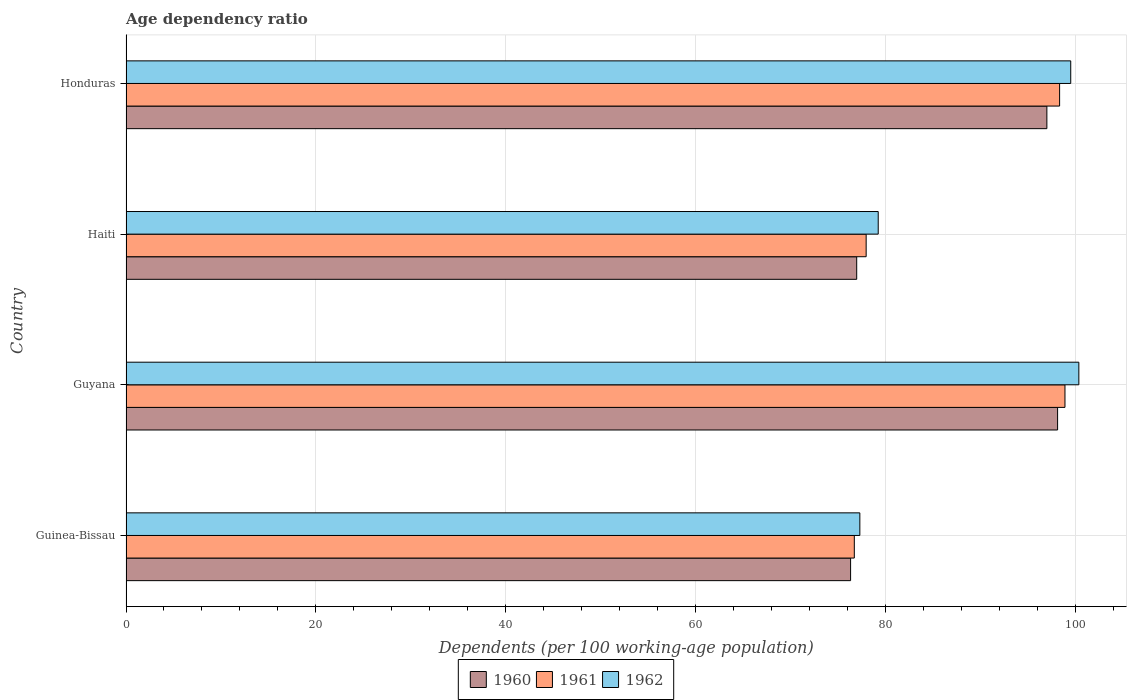How many different coloured bars are there?
Give a very brief answer. 3. How many groups of bars are there?
Offer a very short reply. 4. Are the number of bars per tick equal to the number of legend labels?
Give a very brief answer. Yes. What is the label of the 1st group of bars from the top?
Give a very brief answer. Honduras. In how many cases, is the number of bars for a given country not equal to the number of legend labels?
Offer a terse response. 0. What is the age dependency ratio in in 1962 in Guyana?
Offer a very short reply. 100.39. Across all countries, what is the maximum age dependency ratio in in 1962?
Provide a succinct answer. 100.39. Across all countries, what is the minimum age dependency ratio in in 1961?
Give a very brief answer. 76.74. In which country was the age dependency ratio in in 1962 maximum?
Make the answer very short. Guyana. In which country was the age dependency ratio in in 1962 minimum?
Keep it short and to the point. Guinea-Bissau. What is the total age dependency ratio in in 1960 in the graph?
Your answer should be compact. 348.51. What is the difference between the age dependency ratio in in 1962 in Guinea-Bissau and that in Honduras?
Your answer should be compact. -22.22. What is the difference between the age dependency ratio in in 1961 in Honduras and the age dependency ratio in in 1962 in Guinea-Bissau?
Your answer should be compact. 21.05. What is the average age dependency ratio in in 1962 per country?
Your answer should be very brief. 89.13. What is the difference between the age dependency ratio in in 1960 and age dependency ratio in in 1961 in Guyana?
Your response must be concise. -0.78. In how many countries, is the age dependency ratio in in 1961 greater than 44 %?
Your answer should be very brief. 4. What is the ratio of the age dependency ratio in in 1961 in Haiti to that in Honduras?
Ensure brevity in your answer.  0.79. Is the difference between the age dependency ratio in in 1960 in Guyana and Haiti greater than the difference between the age dependency ratio in in 1961 in Guyana and Haiti?
Offer a very short reply. Yes. What is the difference between the highest and the second highest age dependency ratio in in 1962?
Offer a terse response. 0.86. What is the difference between the highest and the lowest age dependency ratio in in 1960?
Your answer should be compact. 21.81. In how many countries, is the age dependency ratio in in 1962 greater than the average age dependency ratio in in 1962 taken over all countries?
Your answer should be compact. 2. Is the sum of the age dependency ratio in in 1961 in Guinea-Bissau and Guyana greater than the maximum age dependency ratio in in 1962 across all countries?
Give a very brief answer. Yes. What does the 1st bar from the top in Honduras represents?
Ensure brevity in your answer.  1962. What does the 3rd bar from the bottom in Guyana represents?
Your response must be concise. 1962. Is it the case that in every country, the sum of the age dependency ratio in in 1962 and age dependency ratio in in 1961 is greater than the age dependency ratio in in 1960?
Your answer should be very brief. Yes. How many bars are there?
Offer a terse response. 12. Are all the bars in the graph horizontal?
Offer a very short reply. Yes. How many countries are there in the graph?
Ensure brevity in your answer.  4. What is the difference between two consecutive major ticks on the X-axis?
Ensure brevity in your answer.  20. Are the values on the major ticks of X-axis written in scientific E-notation?
Make the answer very short. No. Does the graph contain any zero values?
Your response must be concise. No. How are the legend labels stacked?
Offer a terse response. Horizontal. What is the title of the graph?
Provide a succinct answer. Age dependency ratio. What is the label or title of the X-axis?
Your response must be concise. Dependents (per 100 working-age population). What is the Dependents (per 100 working-age population) of 1960 in Guinea-Bissau?
Keep it short and to the point. 76.34. What is the Dependents (per 100 working-age population) of 1961 in Guinea-Bissau?
Offer a very short reply. 76.74. What is the Dependents (per 100 working-age population) of 1962 in Guinea-Bissau?
Provide a succinct answer. 77.32. What is the Dependents (per 100 working-age population) in 1960 in Guyana?
Your response must be concise. 98.15. What is the Dependents (per 100 working-age population) in 1961 in Guyana?
Provide a short and direct response. 98.93. What is the Dependents (per 100 working-age population) in 1962 in Guyana?
Offer a terse response. 100.39. What is the Dependents (per 100 working-age population) in 1960 in Haiti?
Ensure brevity in your answer.  76.99. What is the Dependents (per 100 working-age population) in 1961 in Haiti?
Your response must be concise. 77.98. What is the Dependents (per 100 working-age population) in 1962 in Haiti?
Your answer should be compact. 79.25. What is the Dependents (per 100 working-age population) in 1960 in Honduras?
Offer a terse response. 97.02. What is the Dependents (per 100 working-age population) in 1961 in Honduras?
Offer a terse response. 98.37. What is the Dependents (per 100 working-age population) of 1962 in Honduras?
Provide a short and direct response. 99.54. Across all countries, what is the maximum Dependents (per 100 working-age population) of 1960?
Provide a succinct answer. 98.15. Across all countries, what is the maximum Dependents (per 100 working-age population) in 1961?
Provide a succinct answer. 98.93. Across all countries, what is the maximum Dependents (per 100 working-age population) of 1962?
Provide a short and direct response. 100.39. Across all countries, what is the minimum Dependents (per 100 working-age population) of 1960?
Provide a succinct answer. 76.34. Across all countries, what is the minimum Dependents (per 100 working-age population) in 1961?
Provide a short and direct response. 76.74. Across all countries, what is the minimum Dependents (per 100 working-age population) of 1962?
Offer a very short reply. 77.32. What is the total Dependents (per 100 working-age population) in 1960 in the graph?
Your answer should be very brief. 348.51. What is the total Dependents (per 100 working-age population) in 1961 in the graph?
Keep it short and to the point. 352.01. What is the total Dependents (per 100 working-age population) of 1962 in the graph?
Provide a succinct answer. 356.5. What is the difference between the Dependents (per 100 working-age population) in 1960 in Guinea-Bissau and that in Guyana?
Offer a very short reply. -21.81. What is the difference between the Dependents (per 100 working-age population) in 1961 in Guinea-Bissau and that in Guyana?
Offer a terse response. -22.19. What is the difference between the Dependents (per 100 working-age population) in 1962 in Guinea-Bissau and that in Guyana?
Offer a terse response. -23.08. What is the difference between the Dependents (per 100 working-age population) in 1960 in Guinea-Bissau and that in Haiti?
Your response must be concise. -0.64. What is the difference between the Dependents (per 100 working-age population) in 1961 in Guinea-Bissau and that in Haiti?
Offer a very short reply. -1.25. What is the difference between the Dependents (per 100 working-age population) of 1962 in Guinea-Bissau and that in Haiti?
Provide a succinct answer. -1.94. What is the difference between the Dependents (per 100 working-age population) in 1960 in Guinea-Bissau and that in Honduras?
Keep it short and to the point. -20.68. What is the difference between the Dependents (per 100 working-age population) of 1961 in Guinea-Bissau and that in Honduras?
Offer a terse response. -21.63. What is the difference between the Dependents (per 100 working-age population) of 1962 in Guinea-Bissau and that in Honduras?
Give a very brief answer. -22.22. What is the difference between the Dependents (per 100 working-age population) in 1960 in Guyana and that in Haiti?
Your answer should be very brief. 21.17. What is the difference between the Dependents (per 100 working-age population) of 1961 in Guyana and that in Haiti?
Keep it short and to the point. 20.95. What is the difference between the Dependents (per 100 working-age population) in 1962 in Guyana and that in Haiti?
Provide a short and direct response. 21.14. What is the difference between the Dependents (per 100 working-age population) of 1960 in Guyana and that in Honduras?
Ensure brevity in your answer.  1.13. What is the difference between the Dependents (per 100 working-age population) in 1961 in Guyana and that in Honduras?
Make the answer very short. 0.56. What is the difference between the Dependents (per 100 working-age population) of 1962 in Guyana and that in Honduras?
Make the answer very short. 0.86. What is the difference between the Dependents (per 100 working-age population) in 1960 in Haiti and that in Honduras?
Your answer should be very brief. -20.04. What is the difference between the Dependents (per 100 working-age population) of 1961 in Haiti and that in Honduras?
Make the answer very short. -20.38. What is the difference between the Dependents (per 100 working-age population) of 1962 in Haiti and that in Honduras?
Provide a short and direct response. -20.28. What is the difference between the Dependents (per 100 working-age population) in 1960 in Guinea-Bissau and the Dependents (per 100 working-age population) in 1961 in Guyana?
Your answer should be compact. -22.59. What is the difference between the Dependents (per 100 working-age population) of 1960 in Guinea-Bissau and the Dependents (per 100 working-age population) of 1962 in Guyana?
Give a very brief answer. -24.05. What is the difference between the Dependents (per 100 working-age population) in 1961 in Guinea-Bissau and the Dependents (per 100 working-age population) in 1962 in Guyana?
Ensure brevity in your answer.  -23.66. What is the difference between the Dependents (per 100 working-age population) in 1960 in Guinea-Bissau and the Dependents (per 100 working-age population) in 1961 in Haiti?
Offer a very short reply. -1.64. What is the difference between the Dependents (per 100 working-age population) of 1960 in Guinea-Bissau and the Dependents (per 100 working-age population) of 1962 in Haiti?
Your answer should be compact. -2.91. What is the difference between the Dependents (per 100 working-age population) of 1961 in Guinea-Bissau and the Dependents (per 100 working-age population) of 1962 in Haiti?
Your response must be concise. -2.52. What is the difference between the Dependents (per 100 working-age population) of 1960 in Guinea-Bissau and the Dependents (per 100 working-age population) of 1961 in Honduras?
Provide a short and direct response. -22.02. What is the difference between the Dependents (per 100 working-age population) of 1960 in Guinea-Bissau and the Dependents (per 100 working-age population) of 1962 in Honduras?
Offer a terse response. -23.19. What is the difference between the Dependents (per 100 working-age population) of 1961 in Guinea-Bissau and the Dependents (per 100 working-age population) of 1962 in Honduras?
Offer a terse response. -22.8. What is the difference between the Dependents (per 100 working-age population) of 1960 in Guyana and the Dependents (per 100 working-age population) of 1961 in Haiti?
Provide a short and direct response. 20.17. What is the difference between the Dependents (per 100 working-age population) of 1960 in Guyana and the Dependents (per 100 working-age population) of 1962 in Haiti?
Your response must be concise. 18.9. What is the difference between the Dependents (per 100 working-age population) in 1961 in Guyana and the Dependents (per 100 working-age population) in 1962 in Haiti?
Your response must be concise. 19.68. What is the difference between the Dependents (per 100 working-age population) in 1960 in Guyana and the Dependents (per 100 working-age population) in 1961 in Honduras?
Offer a very short reply. -0.21. What is the difference between the Dependents (per 100 working-age population) of 1960 in Guyana and the Dependents (per 100 working-age population) of 1962 in Honduras?
Offer a terse response. -1.38. What is the difference between the Dependents (per 100 working-age population) of 1961 in Guyana and the Dependents (per 100 working-age population) of 1962 in Honduras?
Ensure brevity in your answer.  -0.61. What is the difference between the Dependents (per 100 working-age population) in 1960 in Haiti and the Dependents (per 100 working-age population) in 1961 in Honduras?
Offer a very short reply. -21.38. What is the difference between the Dependents (per 100 working-age population) in 1960 in Haiti and the Dependents (per 100 working-age population) in 1962 in Honduras?
Offer a terse response. -22.55. What is the difference between the Dependents (per 100 working-age population) of 1961 in Haiti and the Dependents (per 100 working-age population) of 1962 in Honduras?
Your response must be concise. -21.56. What is the average Dependents (per 100 working-age population) in 1960 per country?
Ensure brevity in your answer.  87.13. What is the average Dependents (per 100 working-age population) in 1961 per country?
Provide a succinct answer. 88. What is the average Dependents (per 100 working-age population) in 1962 per country?
Your response must be concise. 89.13. What is the difference between the Dependents (per 100 working-age population) in 1960 and Dependents (per 100 working-age population) in 1961 in Guinea-Bissau?
Give a very brief answer. -0.39. What is the difference between the Dependents (per 100 working-age population) in 1960 and Dependents (per 100 working-age population) in 1962 in Guinea-Bissau?
Keep it short and to the point. -0.97. What is the difference between the Dependents (per 100 working-age population) in 1961 and Dependents (per 100 working-age population) in 1962 in Guinea-Bissau?
Offer a very short reply. -0.58. What is the difference between the Dependents (per 100 working-age population) in 1960 and Dependents (per 100 working-age population) in 1961 in Guyana?
Offer a very short reply. -0.78. What is the difference between the Dependents (per 100 working-age population) of 1960 and Dependents (per 100 working-age population) of 1962 in Guyana?
Provide a succinct answer. -2.24. What is the difference between the Dependents (per 100 working-age population) of 1961 and Dependents (per 100 working-age population) of 1962 in Guyana?
Make the answer very short. -1.46. What is the difference between the Dependents (per 100 working-age population) in 1960 and Dependents (per 100 working-age population) in 1961 in Haiti?
Your answer should be very brief. -1. What is the difference between the Dependents (per 100 working-age population) of 1960 and Dependents (per 100 working-age population) of 1962 in Haiti?
Make the answer very short. -2.27. What is the difference between the Dependents (per 100 working-age population) in 1961 and Dependents (per 100 working-age population) in 1962 in Haiti?
Your answer should be very brief. -1.27. What is the difference between the Dependents (per 100 working-age population) in 1960 and Dependents (per 100 working-age population) in 1961 in Honduras?
Give a very brief answer. -1.34. What is the difference between the Dependents (per 100 working-age population) of 1960 and Dependents (per 100 working-age population) of 1962 in Honduras?
Offer a very short reply. -2.51. What is the difference between the Dependents (per 100 working-age population) in 1961 and Dependents (per 100 working-age population) in 1962 in Honduras?
Give a very brief answer. -1.17. What is the ratio of the Dependents (per 100 working-age population) of 1961 in Guinea-Bissau to that in Guyana?
Make the answer very short. 0.78. What is the ratio of the Dependents (per 100 working-age population) of 1962 in Guinea-Bissau to that in Guyana?
Provide a succinct answer. 0.77. What is the ratio of the Dependents (per 100 working-age population) of 1962 in Guinea-Bissau to that in Haiti?
Your answer should be very brief. 0.98. What is the ratio of the Dependents (per 100 working-age population) in 1960 in Guinea-Bissau to that in Honduras?
Provide a succinct answer. 0.79. What is the ratio of the Dependents (per 100 working-age population) of 1961 in Guinea-Bissau to that in Honduras?
Your response must be concise. 0.78. What is the ratio of the Dependents (per 100 working-age population) in 1962 in Guinea-Bissau to that in Honduras?
Ensure brevity in your answer.  0.78. What is the ratio of the Dependents (per 100 working-age population) of 1960 in Guyana to that in Haiti?
Make the answer very short. 1.27. What is the ratio of the Dependents (per 100 working-age population) in 1961 in Guyana to that in Haiti?
Provide a short and direct response. 1.27. What is the ratio of the Dependents (per 100 working-age population) of 1962 in Guyana to that in Haiti?
Make the answer very short. 1.27. What is the ratio of the Dependents (per 100 working-age population) of 1960 in Guyana to that in Honduras?
Keep it short and to the point. 1.01. What is the ratio of the Dependents (per 100 working-age population) in 1961 in Guyana to that in Honduras?
Provide a succinct answer. 1.01. What is the ratio of the Dependents (per 100 working-age population) in 1962 in Guyana to that in Honduras?
Provide a short and direct response. 1.01. What is the ratio of the Dependents (per 100 working-age population) in 1960 in Haiti to that in Honduras?
Keep it short and to the point. 0.79. What is the ratio of the Dependents (per 100 working-age population) of 1961 in Haiti to that in Honduras?
Provide a short and direct response. 0.79. What is the ratio of the Dependents (per 100 working-age population) of 1962 in Haiti to that in Honduras?
Give a very brief answer. 0.8. What is the difference between the highest and the second highest Dependents (per 100 working-age population) of 1960?
Your response must be concise. 1.13. What is the difference between the highest and the second highest Dependents (per 100 working-age population) in 1961?
Ensure brevity in your answer.  0.56. What is the difference between the highest and the second highest Dependents (per 100 working-age population) of 1962?
Keep it short and to the point. 0.86. What is the difference between the highest and the lowest Dependents (per 100 working-age population) in 1960?
Make the answer very short. 21.81. What is the difference between the highest and the lowest Dependents (per 100 working-age population) in 1961?
Your answer should be compact. 22.19. What is the difference between the highest and the lowest Dependents (per 100 working-age population) of 1962?
Provide a short and direct response. 23.08. 